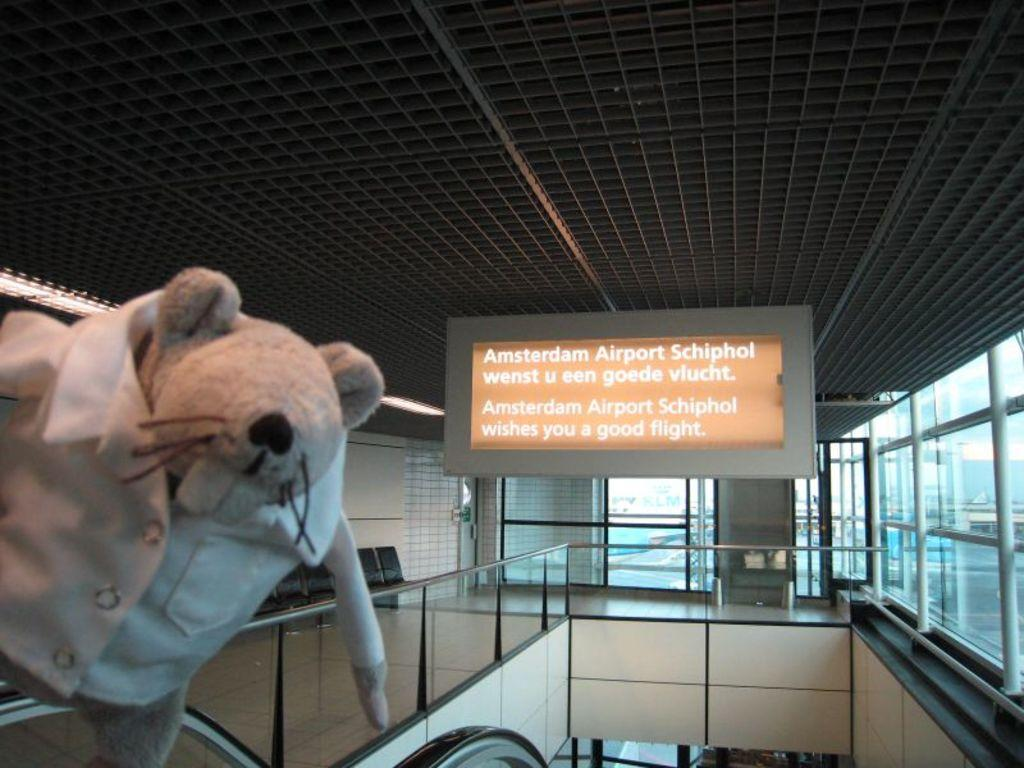What object is located on the left side of the image? There is a teddy bear on the left side of the image. What can be seen in the middle of the image? There is a board in the middle of the image. What type of architectural feature is visible in the background of the image? There is a glass door in the background of the image. What is the value of the teddy bear in the image? The value of the teddy bear cannot be determined from the image alone, as it depends on various factors such as its condition, age, and rarity. What does the board in the middle of the image smell like? The image does not provide any information about the smell of the board, as it is a visual medium. 